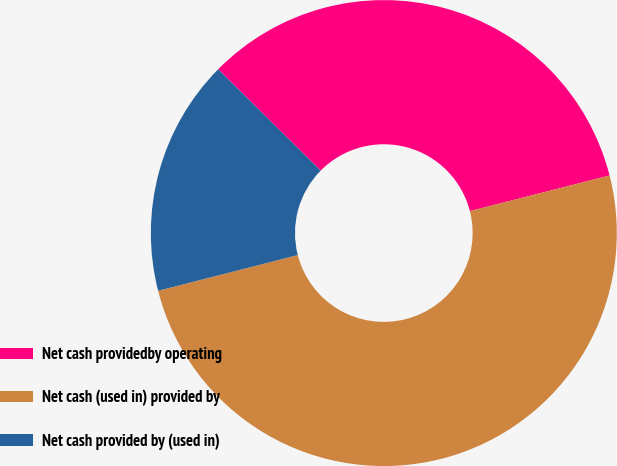Convert chart. <chart><loc_0><loc_0><loc_500><loc_500><pie_chart><fcel>Net cash providedby operating<fcel>Net cash (used in) provided by<fcel>Net cash provided by (used in)<nl><fcel>33.62%<fcel>49.99%<fcel>16.39%<nl></chart> 